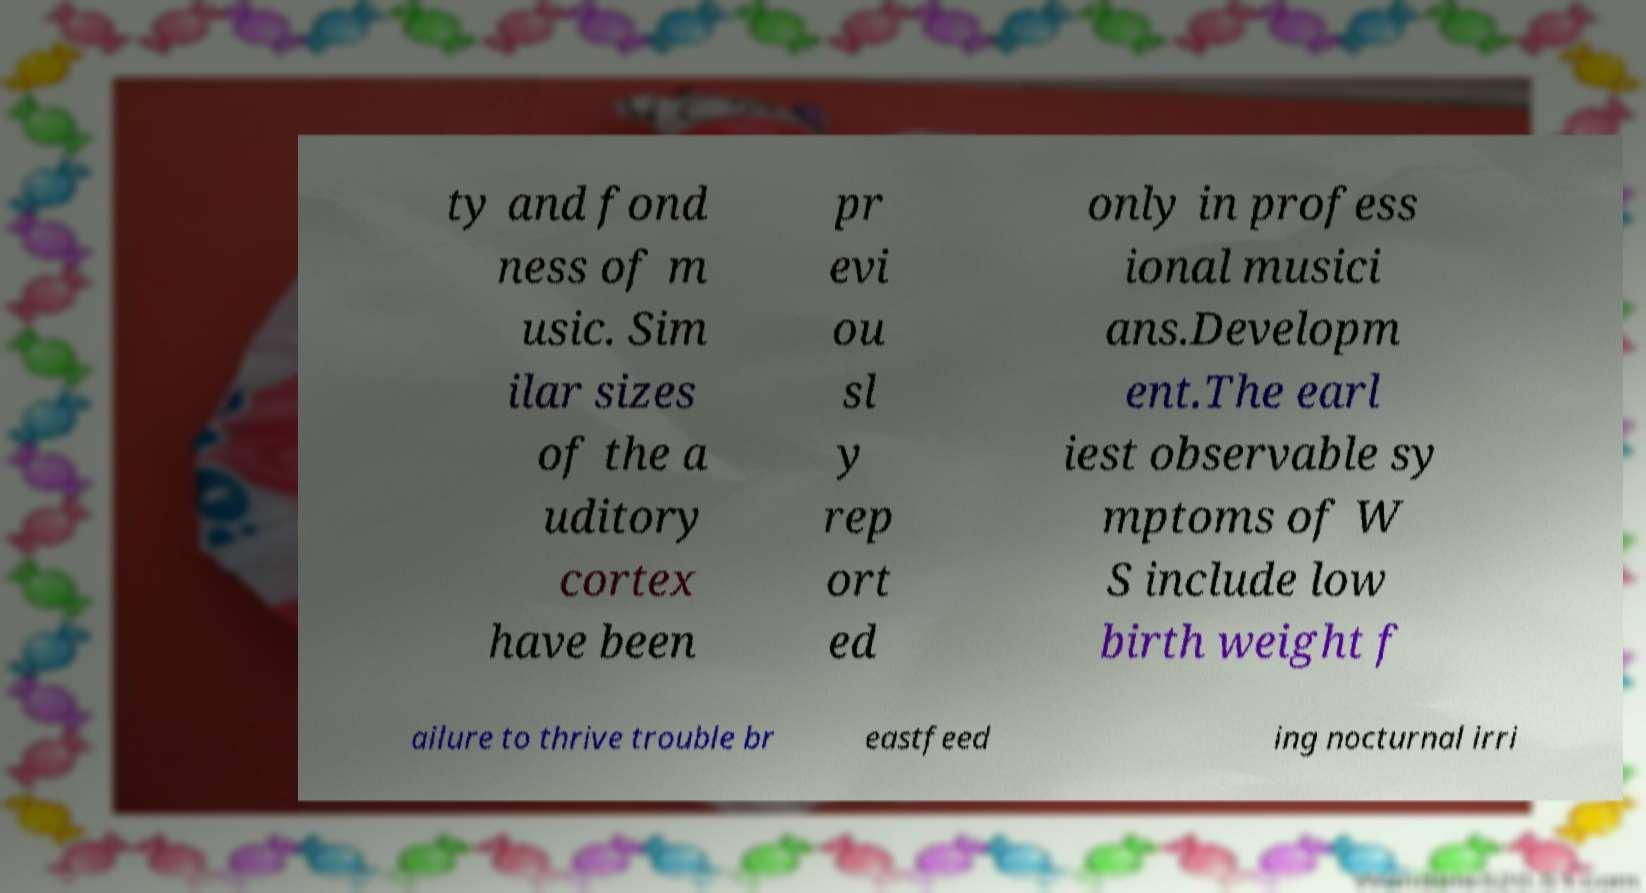For documentation purposes, I need the text within this image transcribed. Could you provide that? ty and fond ness of m usic. Sim ilar sizes of the a uditory cortex have been pr evi ou sl y rep ort ed only in profess ional musici ans.Developm ent.The earl iest observable sy mptoms of W S include low birth weight f ailure to thrive trouble br eastfeed ing nocturnal irri 